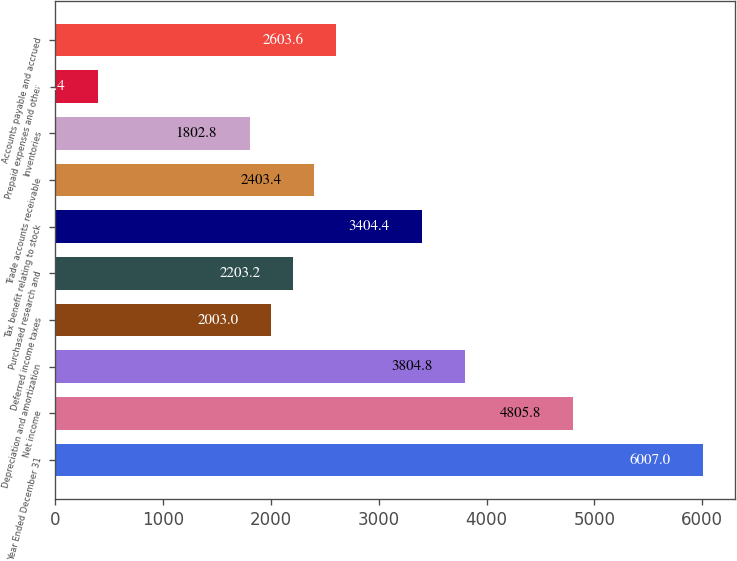Convert chart to OTSL. <chart><loc_0><loc_0><loc_500><loc_500><bar_chart><fcel>Year Ended December 31<fcel>Net income<fcel>Depreciation and amortization<fcel>Deferred income taxes<fcel>Purchased research and<fcel>Tax benefit relating to stock<fcel>Trade accounts receivable<fcel>Inventories<fcel>Prepaid expenses and other<fcel>Accounts payable and accrued<nl><fcel>6007<fcel>4805.8<fcel>3804.8<fcel>2003<fcel>2203.2<fcel>3404.4<fcel>2403.4<fcel>1802.8<fcel>401.4<fcel>2603.6<nl></chart> 